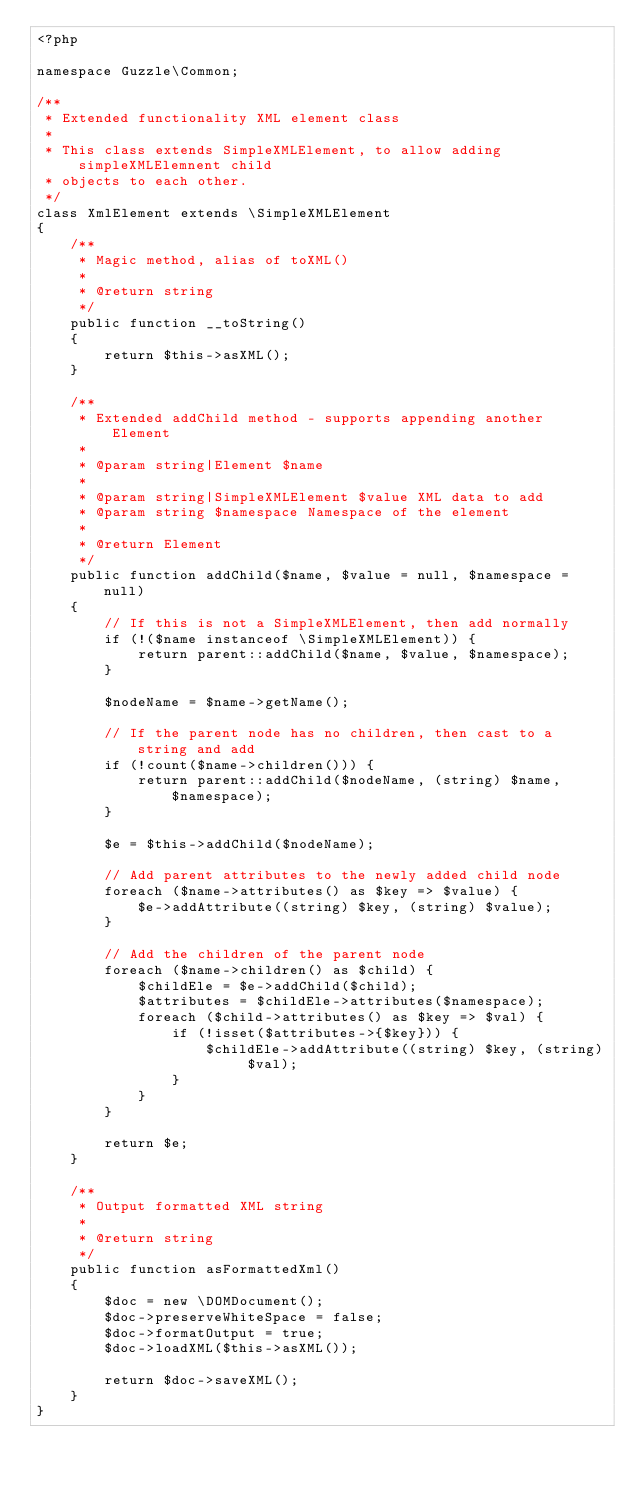<code> <loc_0><loc_0><loc_500><loc_500><_PHP_><?php

namespace Guzzle\Common;

/**
 * Extended functionality XML element class
 *
 * This class extends SimpleXMLElement, to allow adding simpleXMLElemnent child
 * objects to each other.
 */
class XmlElement extends \SimpleXMLElement
{
    /**
     * Magic method, alias of toXML()
     *
     * @return string
     */
    public function __toString()
    {
        return $this->asXML();
    }

    /**
     * Extended addChild method - supports appending another Element
     *
     * @param string|Element $name
     *
     * @param string|SimpleXMLElement $value XML data to add
     * @param string $namespace Namespace of the element
     *
     * @return Element
     */
    public function addChild($name, $value = null, $namespace = null)
    {
        // If this is not a SimpleXMLElement, then add normally
        if (!($name instanceof \SimpleXMLElement)) {
            return parent::addChild($name, $value, $namespace);
        }

        $nodeName = $name->getName();

        // If the parent node has no children, then cast to a string and add
        if (!count($name->children())) {
            return parent::addChild($nodeName, (string) $name, $namespace);
        }

        $e = $this->addChild($nodeName);

        // Add parent attributes to the newly added child node
        foreach ($name->attributes() as $key => $value) {
            $e->addAttribute((string) $key, (string) $value);
        }

        // Add the children of the parent node
        foreach ($name->children() as $child) {
            $childEle = $e->addChild($child);
            $attributes = $childEle->attributes($namespace);
            foreach ($child->attributes() as $key => $val) {
                if (!isset($attributes->{$key})) {
                    $childEle->addAttribute((string) $key, (string) $val);
                }
            }
        }

        return $e;
    }

    /**
     * Output formatted XML string
     *
     * @return string
     */
    public function asFormattedXml()
    {
        $doc = new \DOMDocument();
        $doc->preserveWhiteSpace = false;
        $doc->formatOutput = true;
        $doc->loadXML($this->asXML());

        return $doc->saveXML();
    }
}</code> 